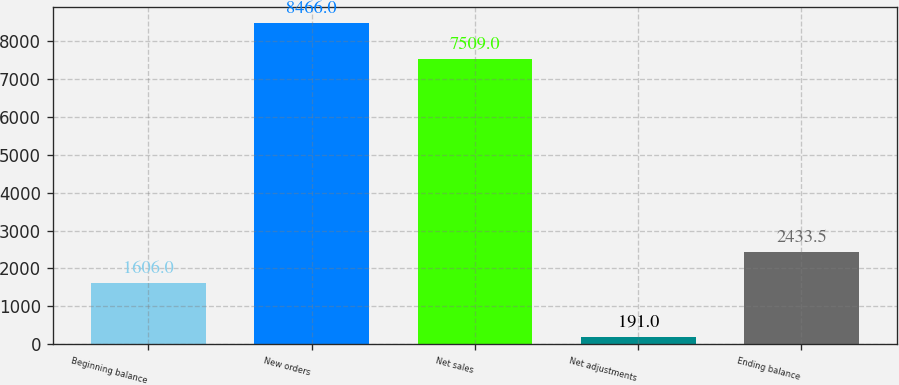Convert chart. <chart><loc_0><loc_0><loc_500><loc_500><bar_chart><fcel>Beginning balance<fcel>New orders<fcel>Net sales<fcel>Net adjustments<fcel>Ending balance<nl><fcel>1606<fcel>8466<fcel>7509<fcel>191<fcel>2433.5<nl></chart> 